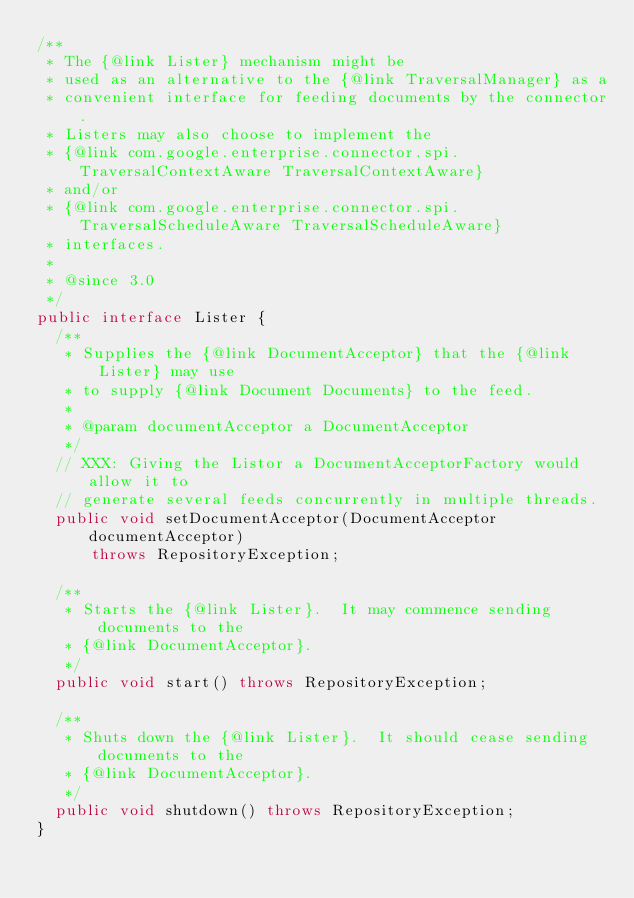Convert code to text. <code><loc_0><loc_0><loc_500><loc_500><_Java_>/**
 * The {@link Lister} mechanism might be
 * used as an alternative to the {@link TraversalManager} as a
 * convenient interface for feeding documents by the connector.
 * Listers may also choose to implement the
 * {@link com.google.enterprise.connector.spi.TraversalContextAware TraversalContextAware}
 * and/or
 * {@link com.google.enterprise.connector.spi.TraversalScheduleAware TraversalScheduleAware}
 * interfaces.
 *
 * @since 3.0
 */
public interface Lister {
  /**
   * Supplies the {@link DocumentAcceptor} that the {@link Lister} may use
   * to supply {@link Document Documents} to the feed.
   *
   * @param documentAcceptor a DocumentAcceptor
   */
  // XXX: Giving the Listor a DocumentAcceptorFactory would allow it to
  // generate several feeds concurrently in multiple threads.
  public void setDocumentAcceptor(DocumentAcceptor documentAcceptor)
      throws RepositoryException;

  /**
   * Starts the {@link Lister}.  It may commence sending documents to the
   * {@link DocumentAcceptor}.
   */
  public void start() throws RepositoryException;

  /**
   * Shuts down the {@link Lister}.  It should cease sending documents to the
   * {@link DocumentAcceptor}.
   */
  public void shutdown() throws RepositoryException;
}
</code> 